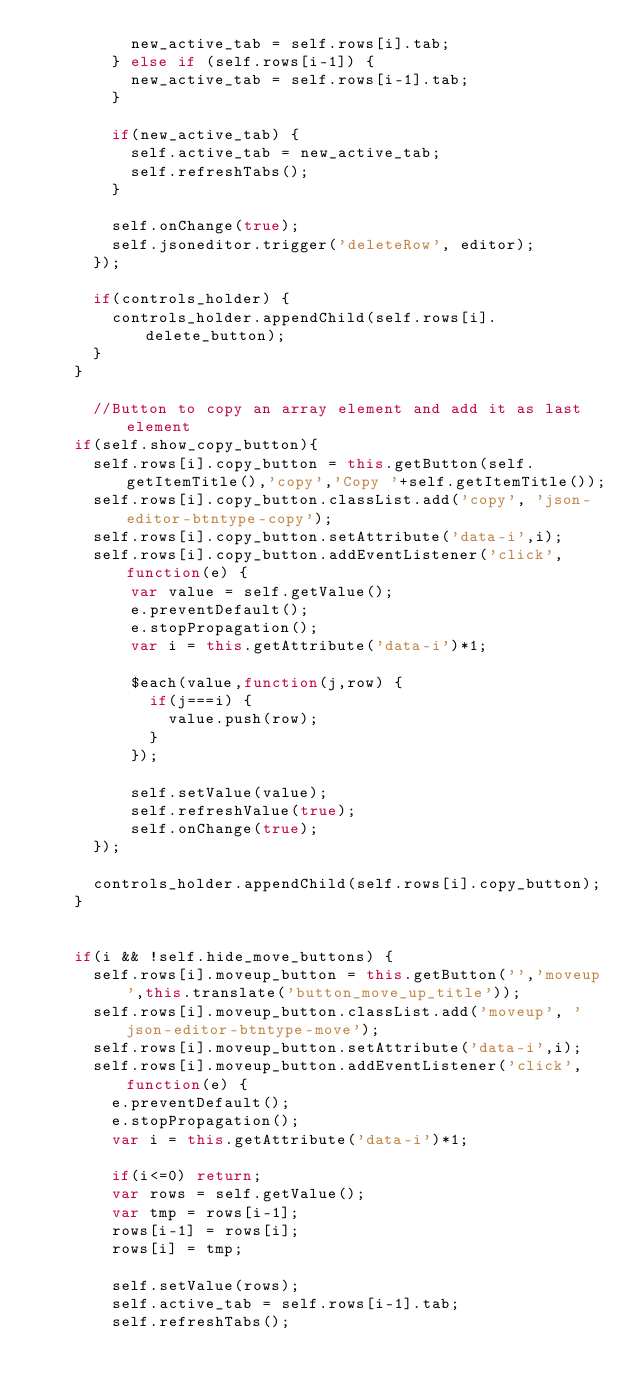Convert code to text. <code><loc_0><loc_0><loc_500><loc_500><_JavaScript_>          new_active_tab = self.rows[i].tab;
        } else if (self.rows[i-1]) {
          new_active_tab = self.rows[i-1].tab;
        }

        if(new_active_tab) {
          self.active_tab = new_active_tab;
          self.refreshTabs();
        }

        self.onChange(true);
        self.jsoneditor.trigger('deleteRow', editor);
      });

      if(controls_holder) {
        controls_holder.appendChild(self.rows[i].delete_button);
      }
    }

	  //Button to copy an array element and add it as last element
    if(self.show_copy_button){
      self.rows[i].copy_button = this.getButton(self.getItemTitle(),'copy','Copy '+self.getItemTitle());
      self.rows[i].copy_button.classList.add('copy', 'json-editor-btntype-copy');
      self.rows[i].copy_button.setAttribute('data-i',i);
      self.rows[i].copy_button.addEventListener('click',function(e) {
          var value = self.getValue();
          e.preventDefault();
          e.stopPropagation();
          var i = this.getAttribute('data-i')*1;

          $each(value,function(j,row) {
            if(j===i) {
              value.push(row);
            }
          });

          self.setValue(value);
          self.refreshValue(true);
          self.onChange(true);
      });

      controls_holder.appendChild(self.rows[i].copy_button);
    }


    if(i && !self.hide_move_buttons) {
      self.rows[i].moveup_button = this.getButton('','moveup',this.translate('button_move_up_title'));
      self.rows[i].moveup_button.classList.add('moveup', 'json-editor-btntype-move');
      self.rows[i].moveup_button.setAttribute('data-i',i);
      self.rows[i].moveup_button.addEventListener('click',function(e) {
        e.preventDefault();
        e.stopPropagation();
        var i = this.getAttribute('data-i')*1;

        if(i<=0) return;
        var rows = self.getValue();
        var tmp = rows[i-1];
        rows[i-1] = rows[i];
        rows[i] = tmp;

        self.setValue(rows);
        self.active_tab = self.rows[i-1].tab;
        self.refreshTabs();
</code> 